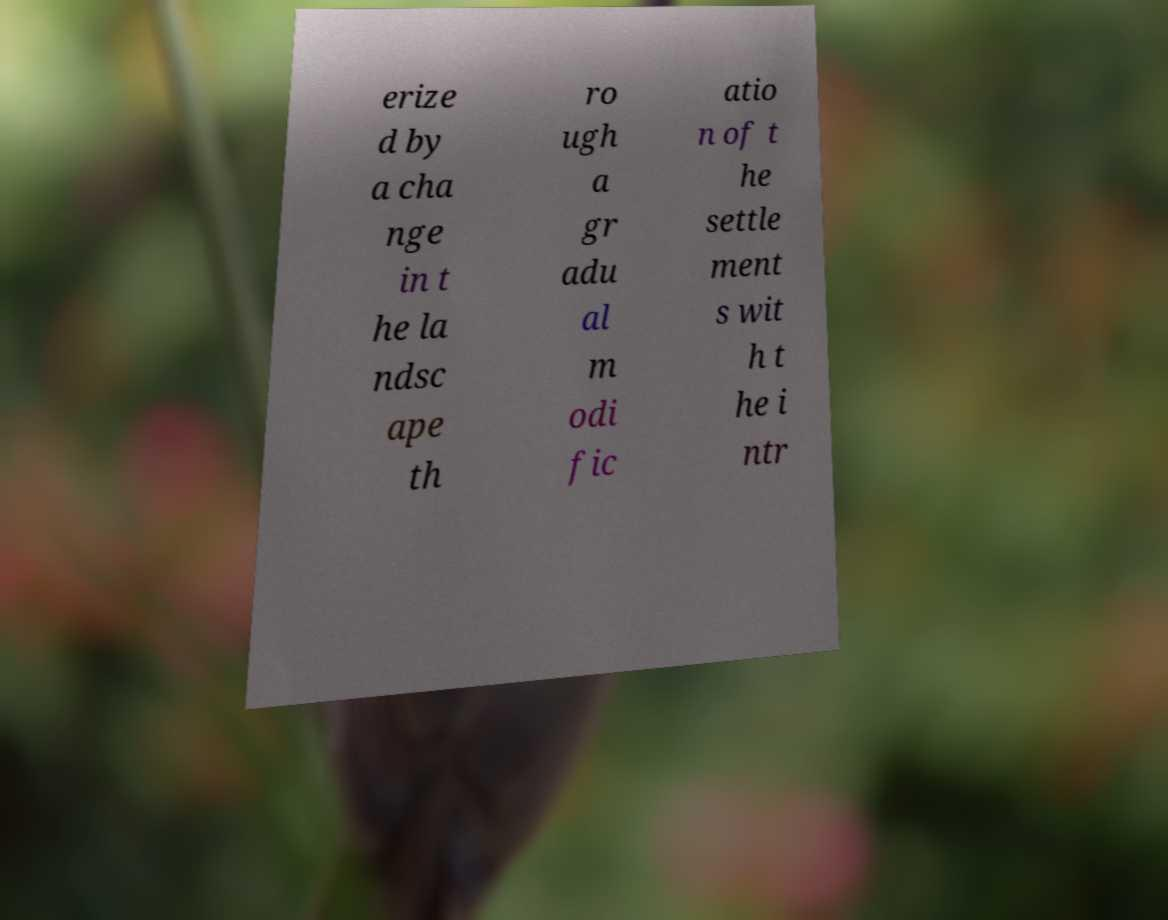I need the written content from this picture converted into text. Can you do that? erize d by a cha nge in t he la ndsc ape th ro ugh a gr adu al m odi fic atio n of t he settle ment s wit h t he i ntr 